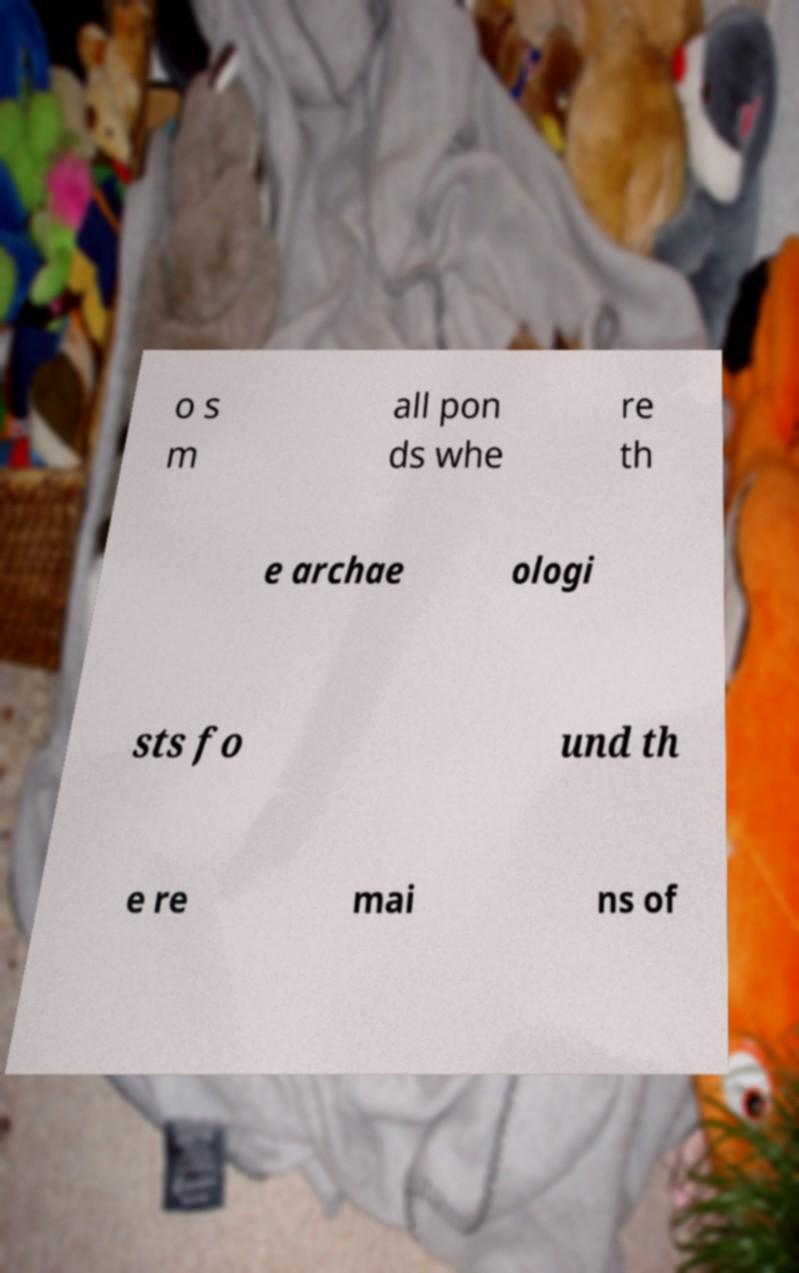For documentation purposes, I need the text within this image transcribed. Could you provide that? o s m all pon ds whe re th e archae ologi sts fo und th e re mai ns of 